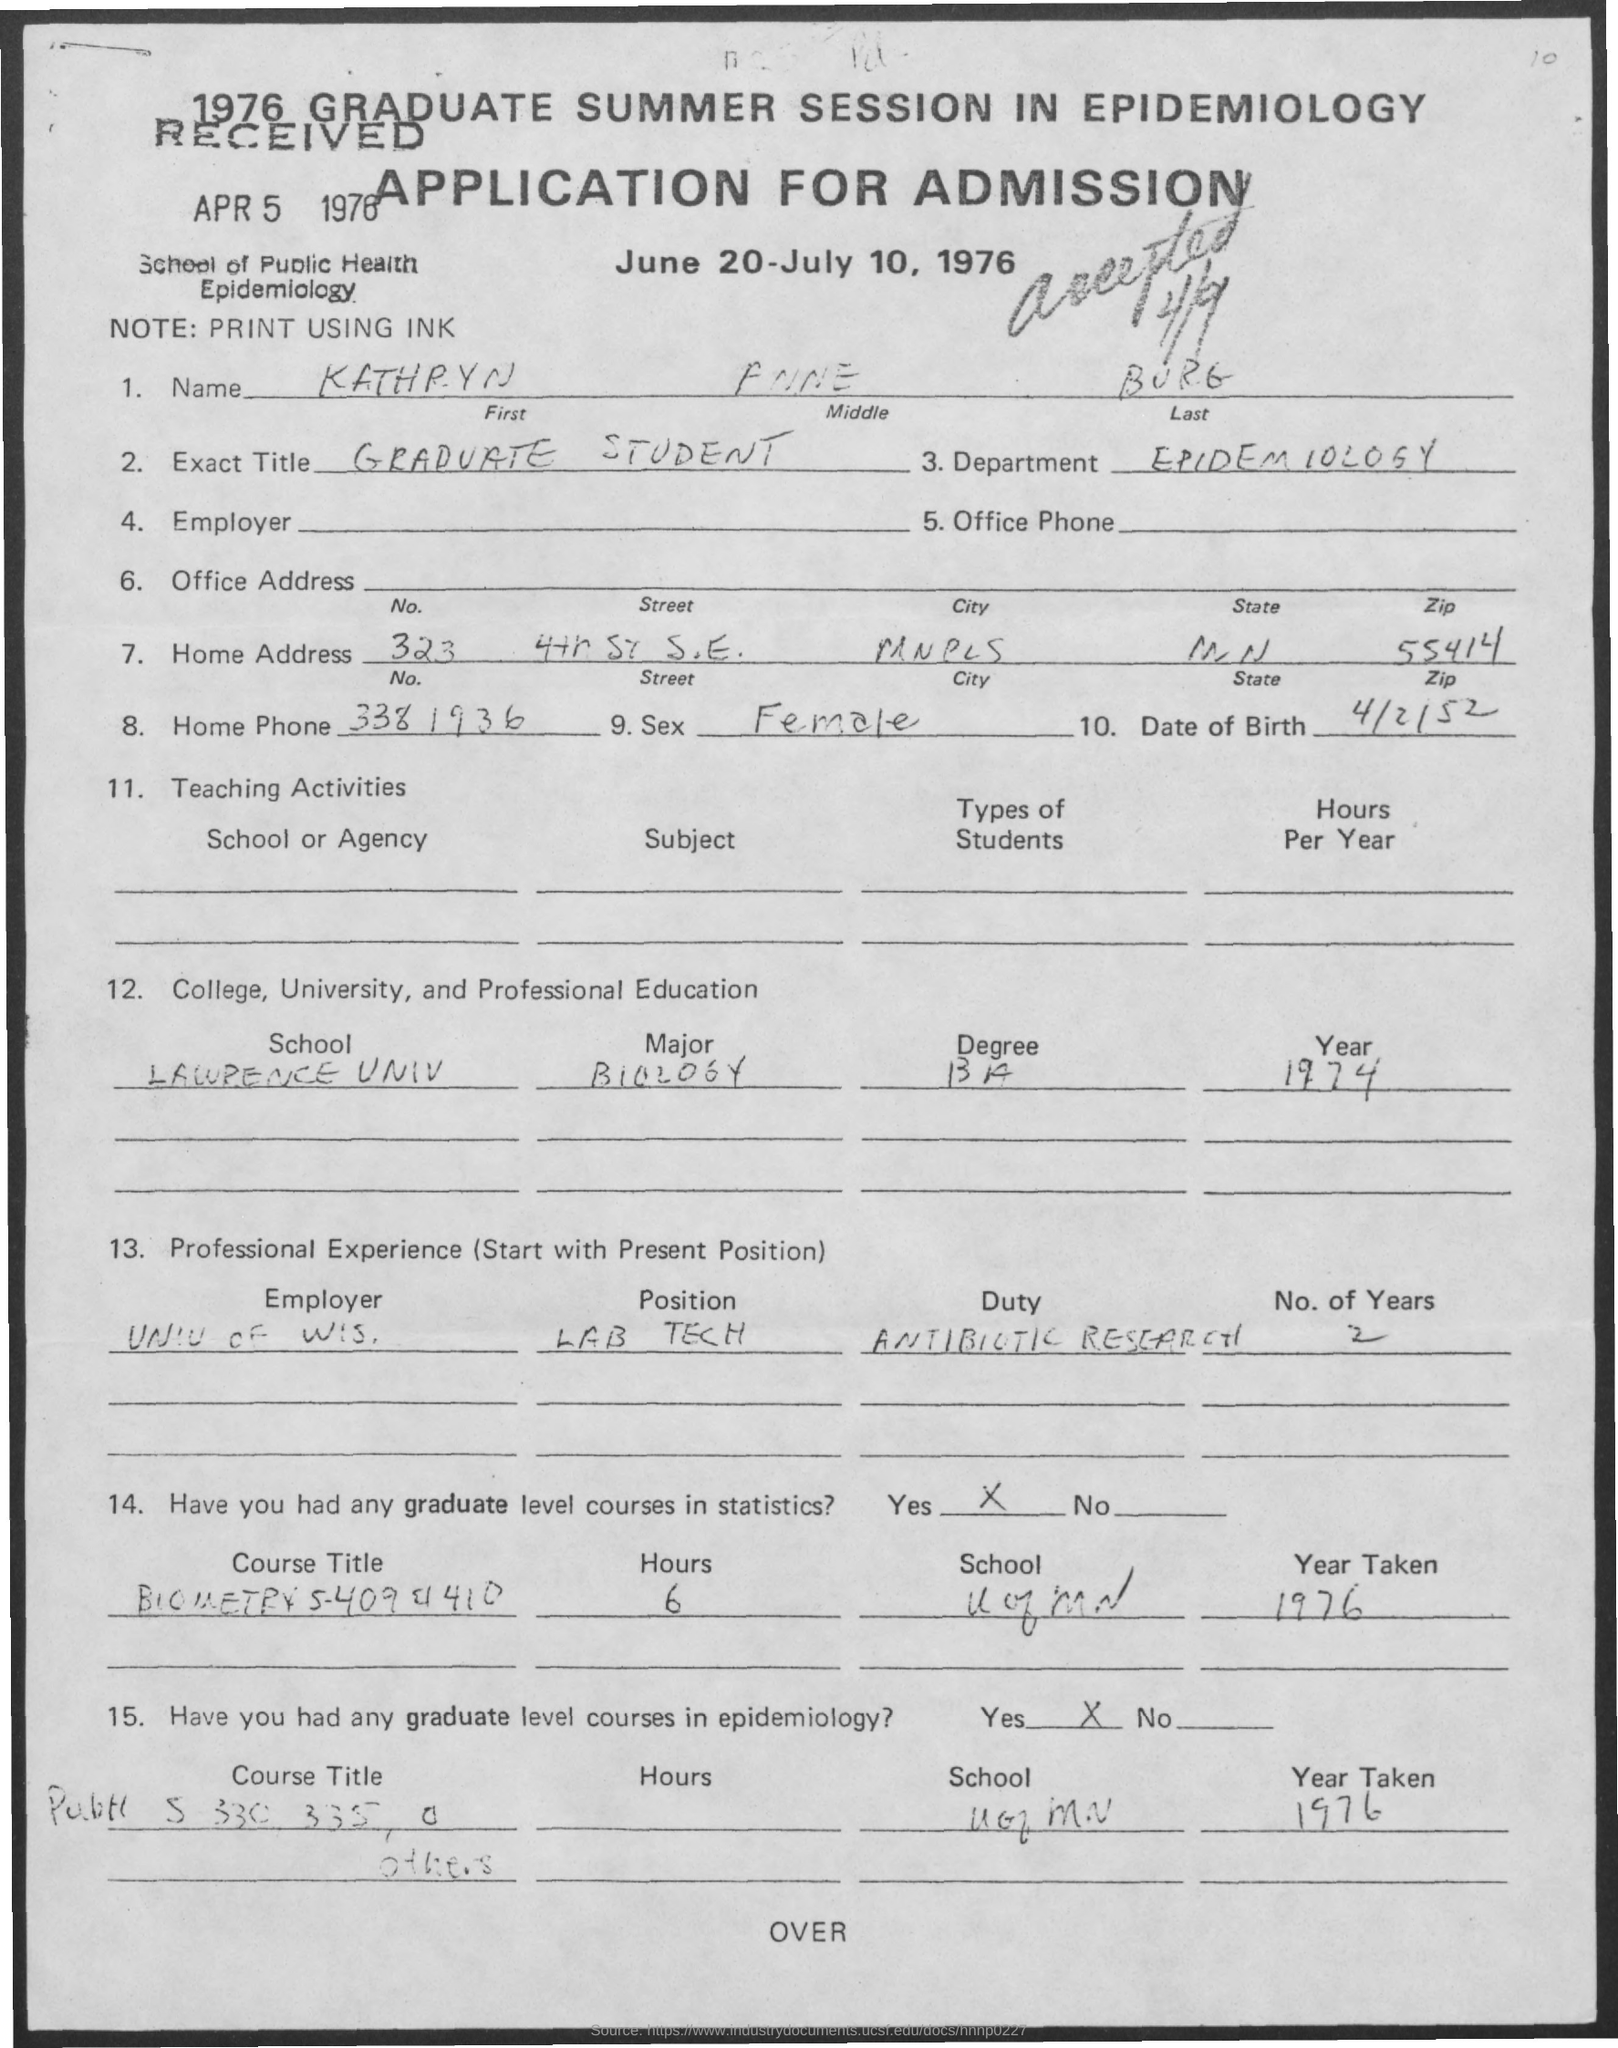Point out several critical features in this image. The zip code for the home address located at 55414 is? The exact title field contains the text 'Graduate Student.' The Department of Epidemiology is a branch of the Department Name that focuses on the study of the distribution and determinants of health-related states or events in specified populations, and the application of this knowledge to the control of diseases and other health problems. The date of birth is April 2, 1952. The sex field has been written as "Female. 